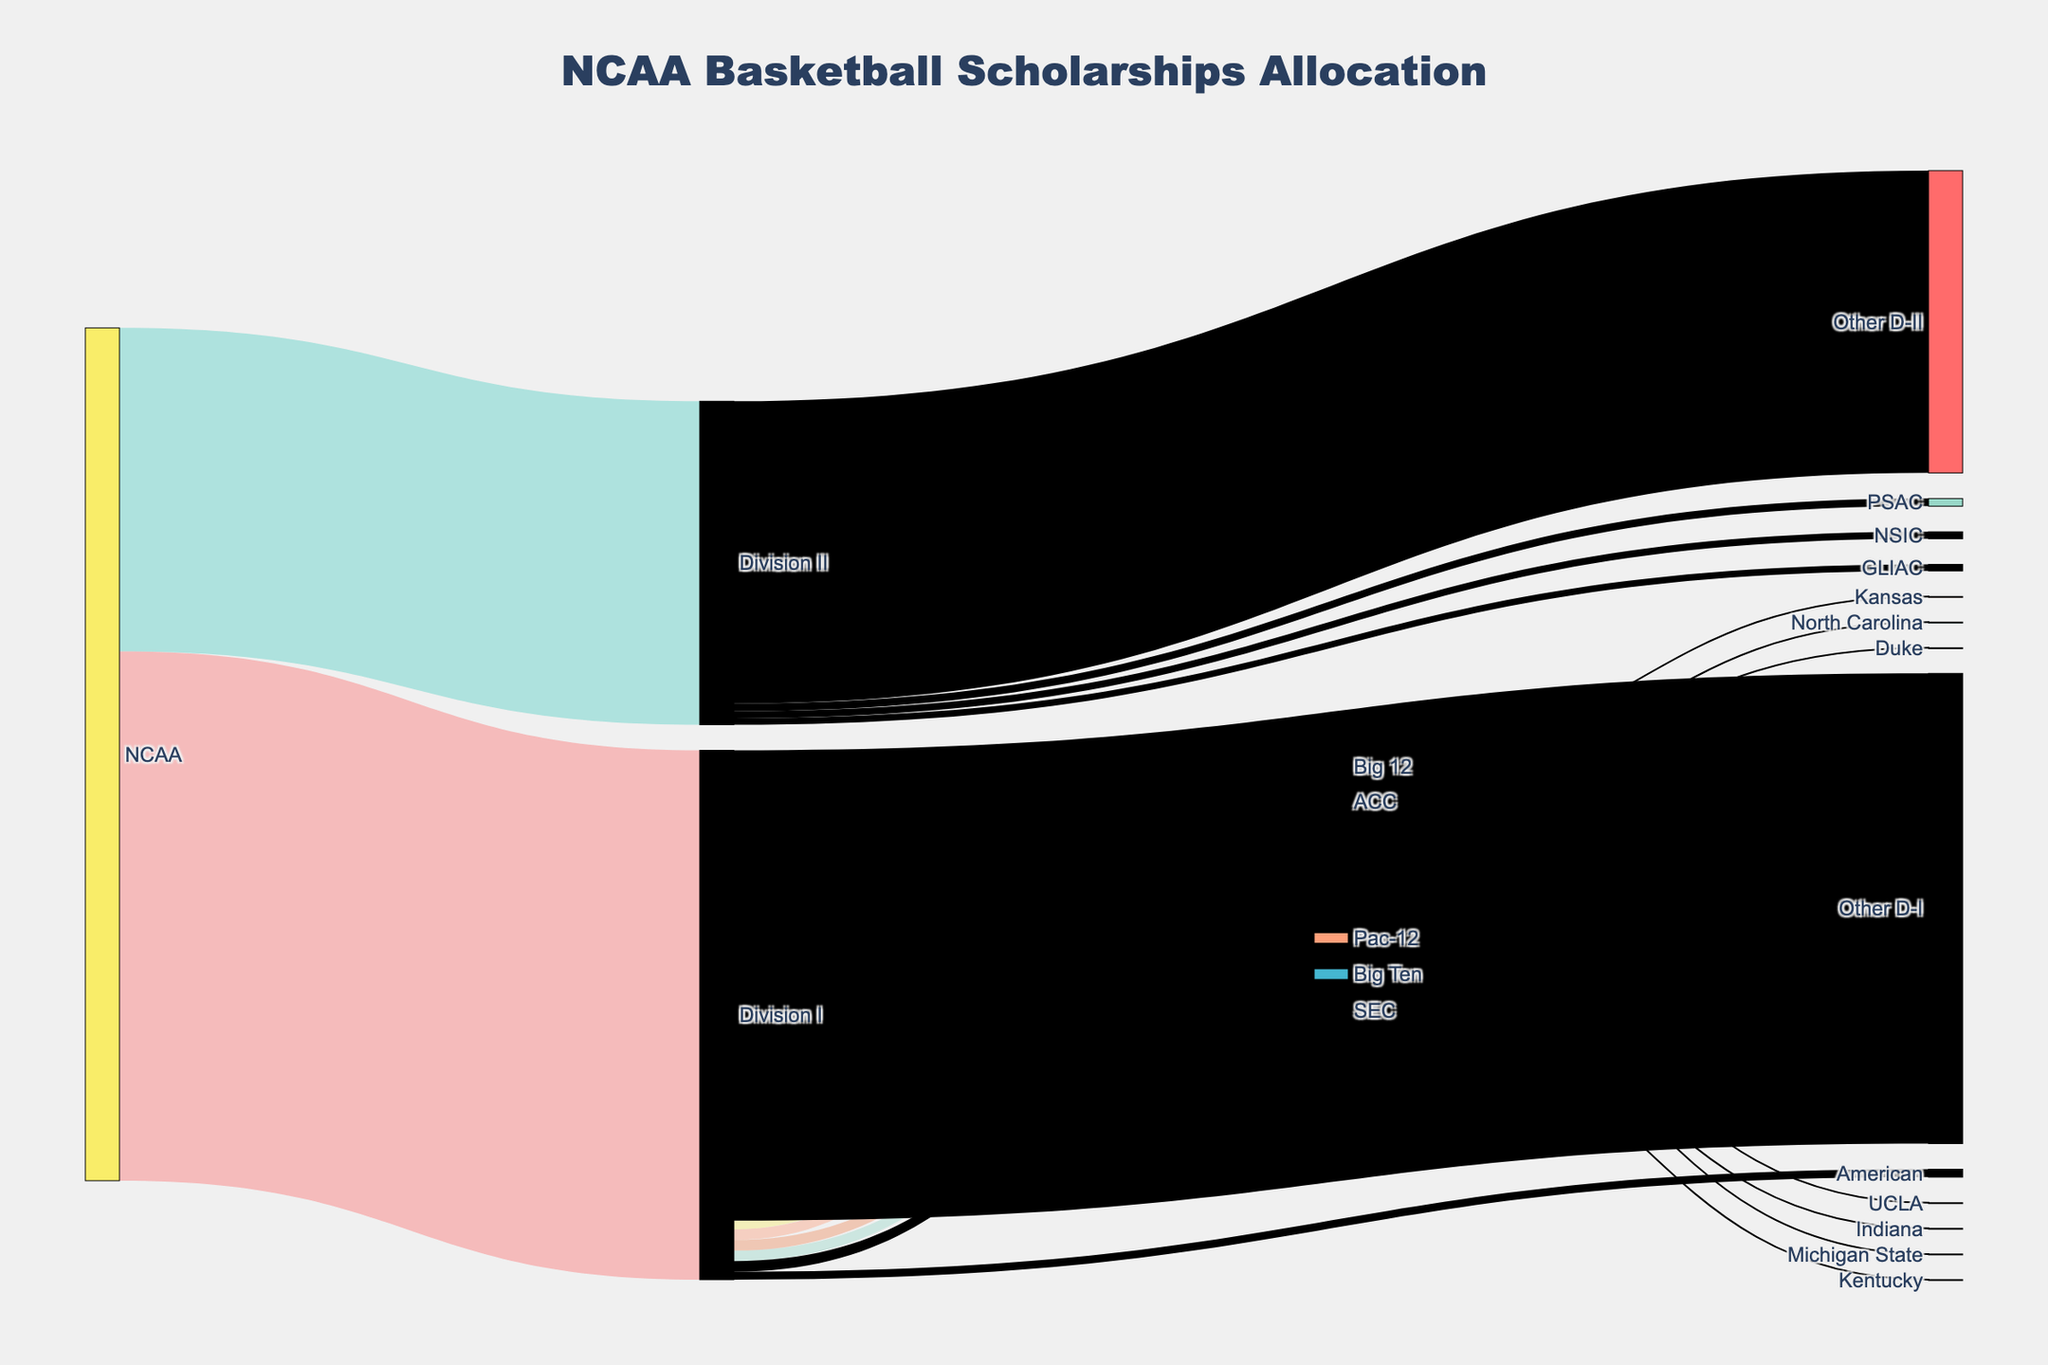Which NCAA division allocates the most basketball scholarships? The Sankey Diagram shows the allocation from NCAA to Division I, Division II, and Division III. Division I has 180,000 scholarships, which is more than Division II (110,000) and Division III (0).
Answer: Division I How many scholarships are allocated to the SEC within Division I? By following the flow in the Sankey Diagram from Division I to SEC, it is shown that SEC receives 3,600 scholarships.
Answer: 3,600 Which team within the Big Ten receives scholarships? In the Sankey Diagram, the Big Ten flows into two teams: Michigan State and Indiana. Hence, these two teams receive scholarships within the Big Ten.
Answer: Michigan State, Indiana What is the total number of scholarships allocated specifically to the teams listed in ACC, Big Ten, Big 12, and Pac-12? Duke, North Carolina (ACC), Michigan State, Indiana (Big Ten), Kansas (Big 12), and UCLA (Pac-12) each receive 13 scholarships. Sum of scholarships: 6 teams × 13 scholarships = 78.
Answer: 78 Compare the total scholarships allocated to ACC and SEC. Which one is higher and by how much? ACC and SEC each receive 3,600 scholarships according to the flow from Division I. Thus, they are equal, and the difference is zero.
Answer: Equal, 0 How many total scholarships are allocated to the conferences within Division II (excluding “Other D-II”)? Summing up the scholarships for GLIAC (2,200), NSIC (2,400), and PSAC (2,600): 2,200 + 2,400 + 2,600 = 7,200 scholarships.
Answer: 7,200 What percentage of all Division I scholarships are allocated to the "Other D-I" category? The total Division I scholarships are 180,000. "Other D-I" receives 159,900. To calculate the percentage: (159,900 / 180,000) × 100 = 88.83%.
Answer: 88.83% Is the allocation to Division III visible in the Sankey Diagram? If not, why? Division III shows 0 scholarships in the Sankey Diagram, indicating no allocation from NCAA to Division III.
Answer: No, because it has 0 scholarships Which conference has more scholarships allocated within Division II: PSAC or GLIAC? According to the Sankey Diagram, PSAC receives 2,600 scholarships, while GLIAC receives 2,200 scholarships. Thus, PSAC has more scholarships.
Answer: PSAC What fraction of Division II scholarships are labeled under "Other D-II"? Division II has 110,000 total scholarships. "Other D-II" receives 102,800. Fraction: 102,800 / 110,000 = 0.9345 or approximately 93.45%.
Answer: 93.45% 